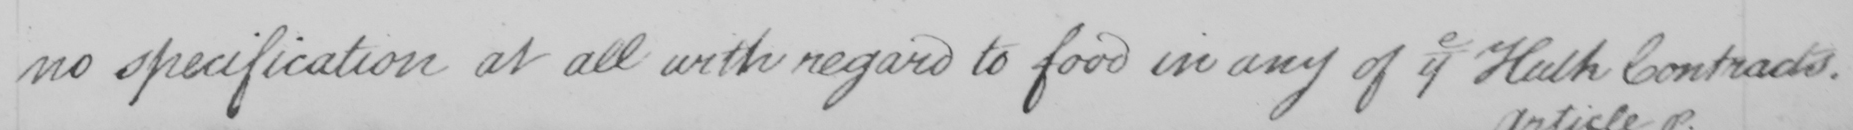Transcribe the text shown in this historical manuscript line. no specification at all with regard to food in any of the Hulk Contracts . 